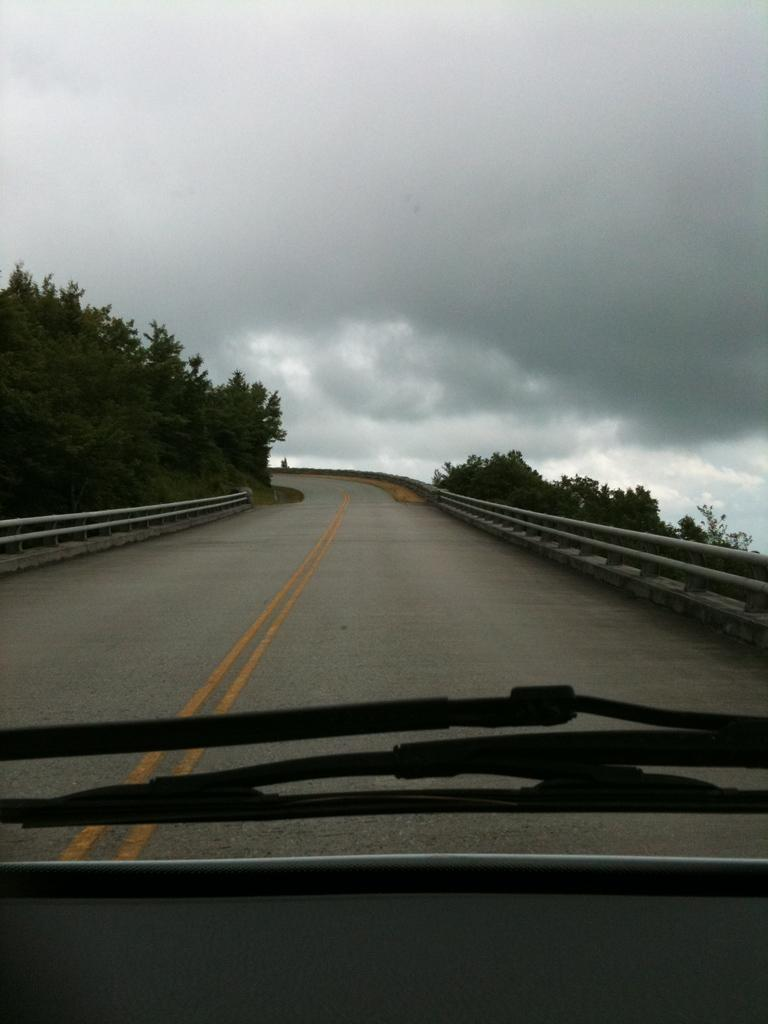What type of pathway is visible in the image? There is a road in the image. What is located near the road in the image? There is fencing in the image. What type of vegetation can be seen in the image? There are trees in the image. What is visible in the background of the image? The sky is visible in the background of the image. How would you describe the weather based on the sky in the image? The sky appears to be cloudy in the image. Where is the vase located in the image? There is no vase present in the image. What type of bubble can be seen in the image? There are no bubbles present in the image. 